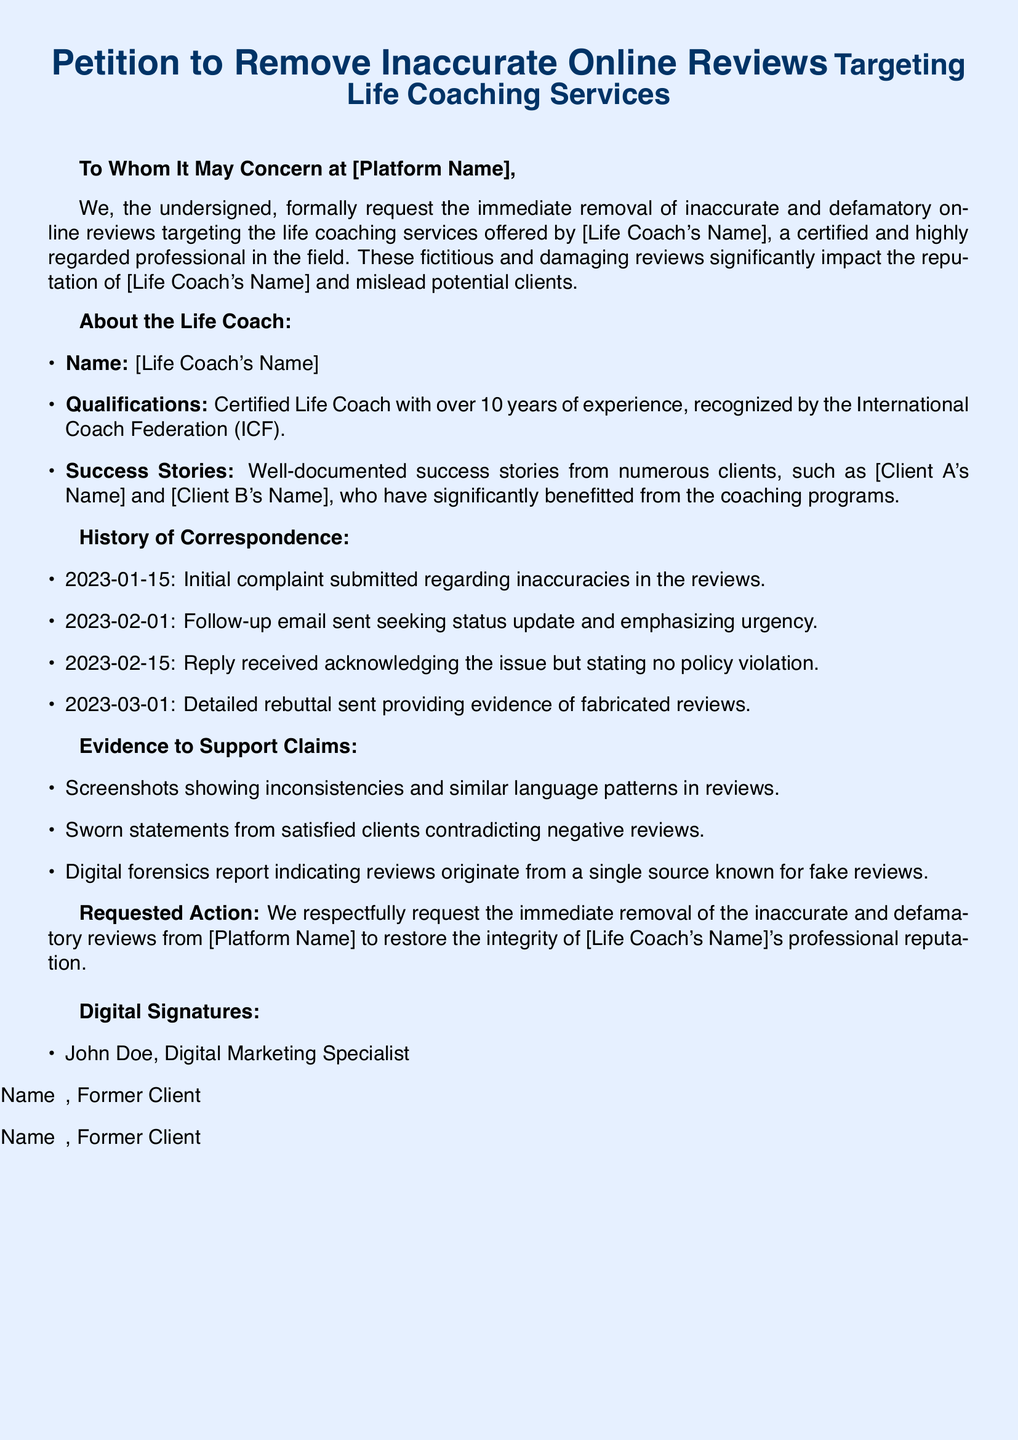What is the name of the life coach? This information is meant to identify the individual whose services are being targeted, but it has been left as a placeholder in the document.
Answer: [Life Coach's Name] How many years of experience does the life coach have? The document states that the life coach has over 10 years of experience.
Answer: over 10 years What date was the initial complaint submitted? The history of correspondence mentions the date when the initial complaint was submitted as part of the timeline.
Answer: 2023-01-15 What type of evidence is mentioned to support the claims? The document lists types of evidence to support claims made against the inaccurate reviews.
Answer: Screenshots How many clients' names are mentioned in the success stories? The document indicates the number of clients whose success stories are highlighted.
Answer: 2 What is the request made to [Platform Name]? The document clearly states the action that is being requested from the platform concerning the reviews.
Answer: removal of the inaccurate and defamatory reviews What professional recognition does the life coach have? The qualifications section mentions the organization's acknowledgment of the life coach, providing credibility.
Answer: International Coach Federation (ICF) What date did the life coach send a detailed rebuttal? The history of correspondence contains specific dates that outline the communication timeline.
Answer: 2023-03-01 